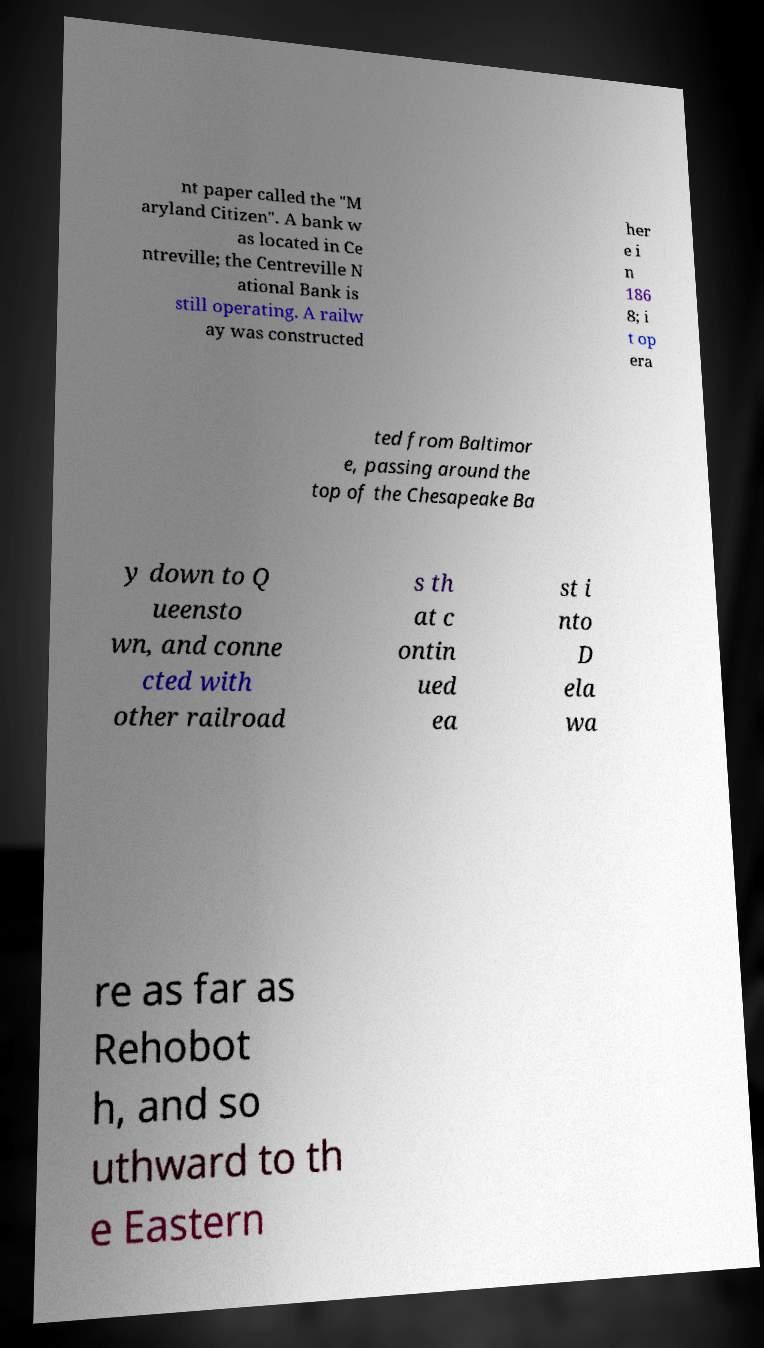I need the written content from this picture converted into text. Can you do that? nt paper called the "M aryland Citizen". A bank w as located in Ce ntreville; the Centreville N ational Bank is still operating. A railw ay was constructed her e i n 186 8; i t op era ted from Baltimor e, passing around the top of the Chesapeake Ba y down to Q ueensto wn, and conne cted with other railroad s th at c ontin ued ea st i nto D ela wa re as far as Rehobot h, and so uthward to th e Eastern 